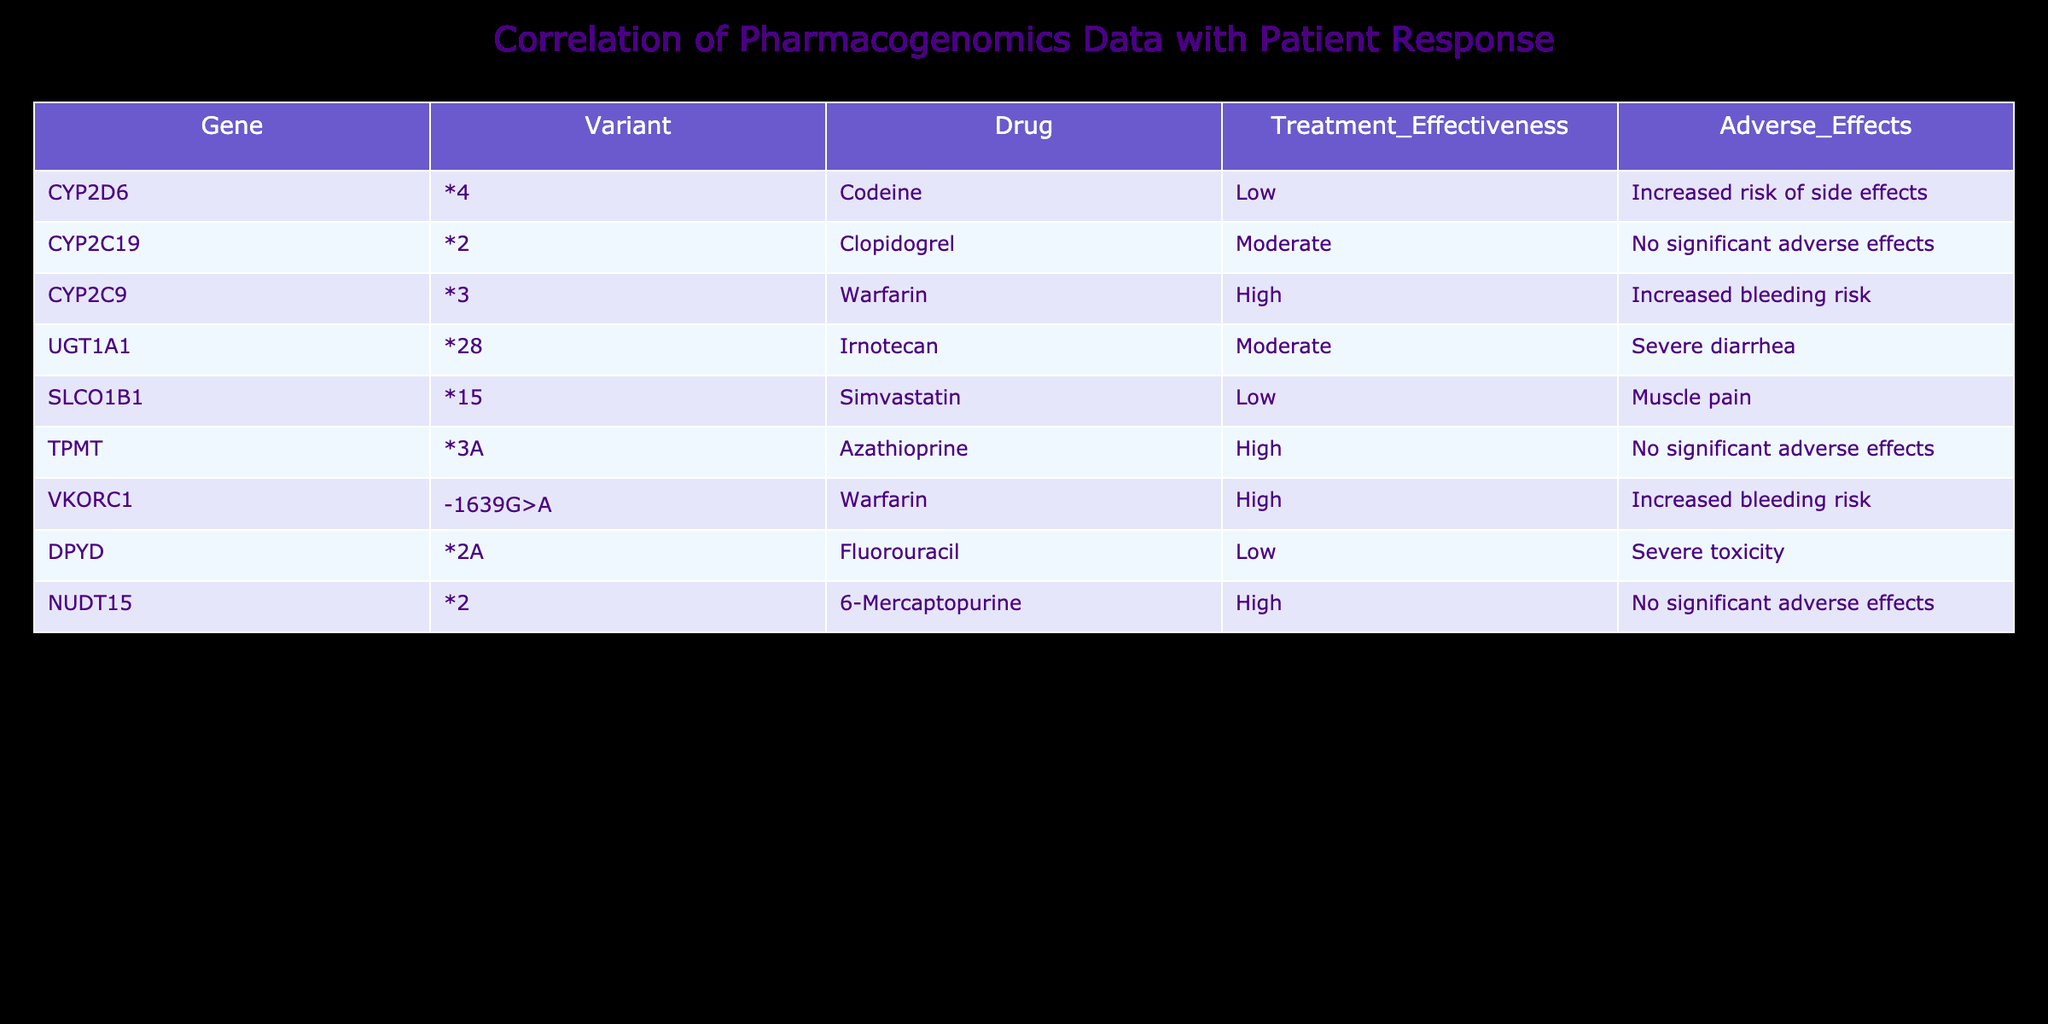What is the treatment effectiveness for Codeine? In the table, under the column "Treatment_Effectiveness" for the drug Codeine, the value is listed as "Low." This value can be directly retrieved from the row associated with Codeine.
Answer: Low Which gene variant is associated with the highest treatment effectiveness? The table contains the "Treatment_Effectiveness" for different gene variants and drugs. By comparing the values, Warfarin associated with the variants CYP2C9*3 and VKORC1-1639G>A both have a "High" treatment effectiveness, which is the highest rating in the table.
Answer: CYP2C9*3 and VKORC1-1639G>A Is there any drug listed that has no significant adverse effects? By reading the "Adverse_Effects" column, we check for any instances of "No significant adverse effects." Clopidogrel and Azathioprine both show this, indicating they do not have significant adverse effects in this correlation.
Answer: Yes What is the total number of drugs with a low treatment effectiveness? The drugs associated with low treatment effectiveness are Codeine, Simvastatin, and Fluorouracil. Counting these entries, there are three drugs in total categorized as low treatment effectiveness.
Answer: 3 Which variant is linked to the highest risk of adverse effects? Examining the "Adverse_Effects" column, Fluorouracil associated with the variant DPYD*2A shows "Severe toxicity," indicating it is linked to the highest risk compared to other entries.
Answer: DPYD*2A Is there a drug that is effective at a high level but has increased risk of side effects? Among the drugs listed, Warfarin shows a "High" effectiveness while also indicating "Increased bleeding risk" in the adverse effects column. This means it is both effective and carries a risk.
Answer: Yes How many variants listed are associated with moderate treatment effectiveness? The table shows UGT1A1*28 and Clopidogrel as having "Moderate" effectiveness. Counting these entries provides the answer of two variants linked to moderate treatment effectiveness.
Answer: 2 What percentage of the listed drugs have a high treatment effectiveness? The drugs with high treatment effectiveness are Warfarin (2 entries) and Azathioprine (1 entry), totaling 3 out of 8 drugs. To find the percentage, (3/8) * 100 = 37.5 percent.
Answer: 37.5% 